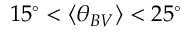<formula> <loc_0><loc_0><loc_500><loc_500>1 5 ^ { \circ } < \langle \theta _ { B V } \rangle < 2 5 ^ { \circ }</formula> 